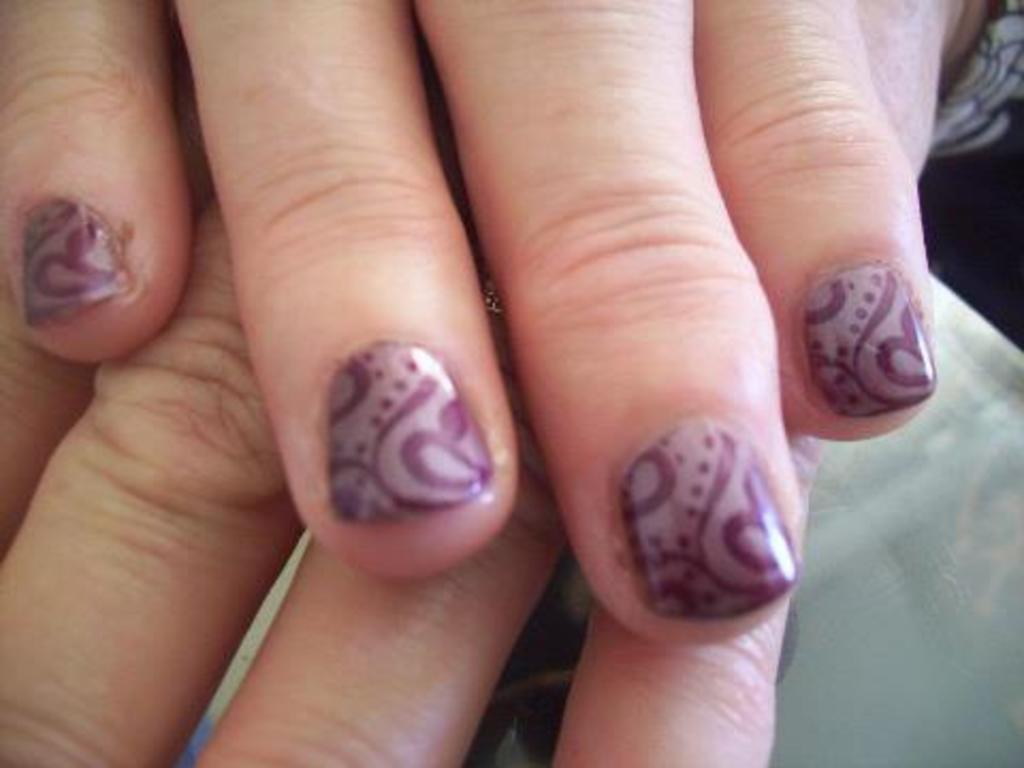What body part is visible in the image? There are hands of a person in the image. What color is the surface on which the hands are resting? The hands are on an ash color surface. What color is the background of the image? The background of the image is black. What type of song is being played in the background of the image? There is no song or audio present in the image; it only features a person's hands on an ash color surface with a black background. 